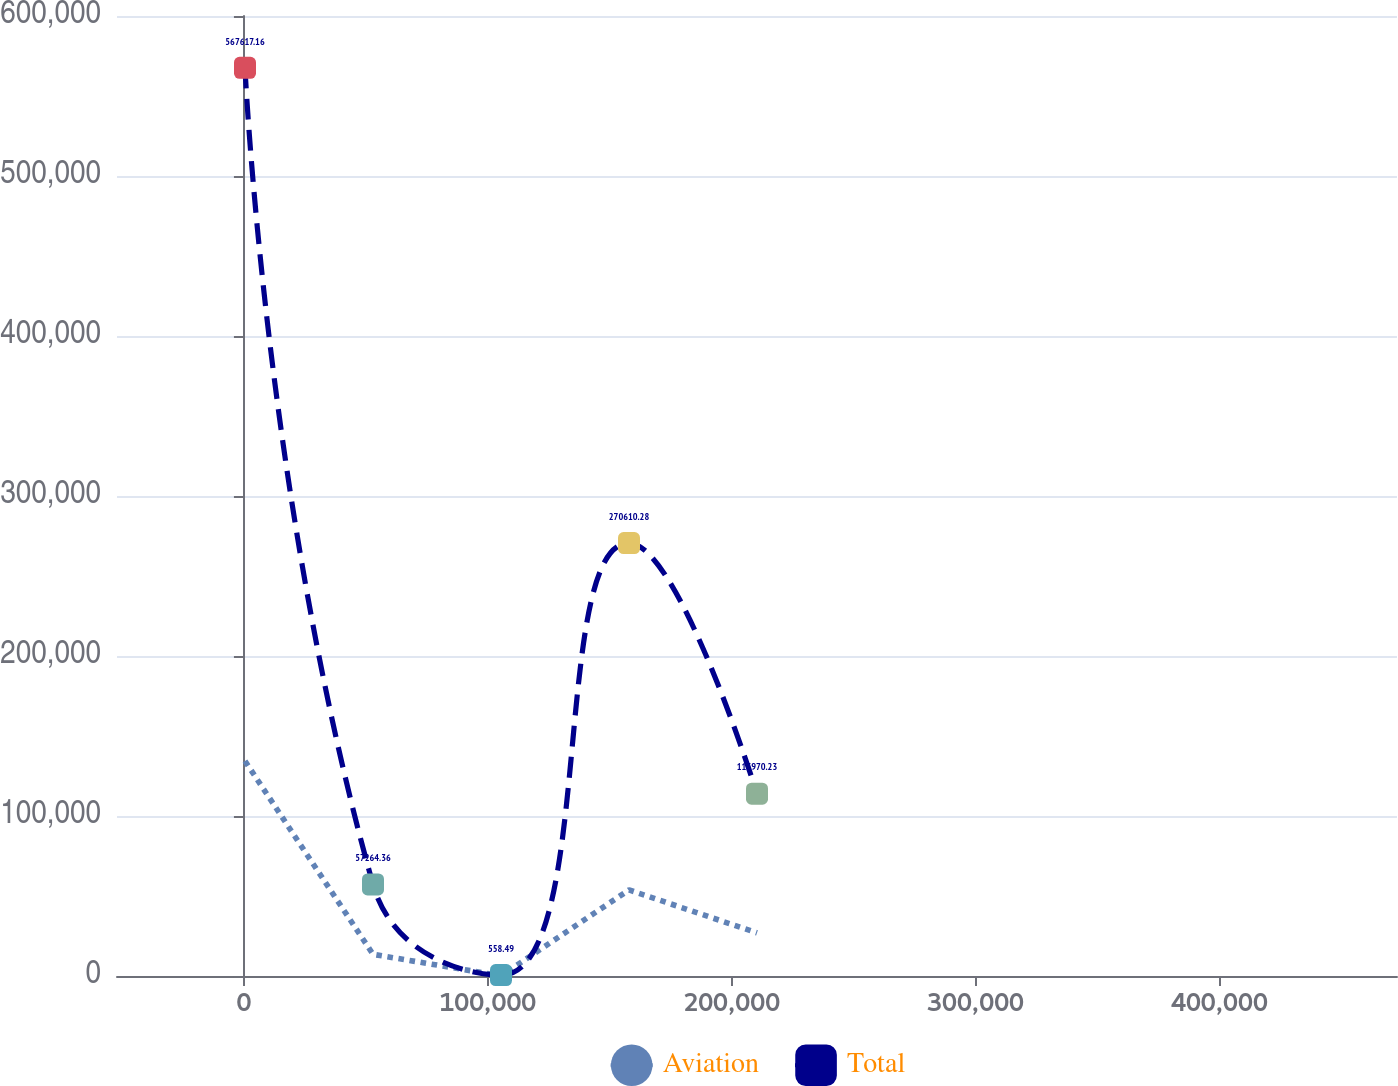<chart> <loc_0><loc_0><loc_500><loc_500><line_chart><ecel><fcel>Aviation<fcel>Total<nl><fcel>436.49<fcel>134334<fcel>567617<nl><fcel>52923.2<fcel>13547.8<fcel>57264.4<nl><fcel>105410<fcel>127.19<fcel>558.49<nl><fcel>157896<fcel>53809.7<fcel>270610<nl><fcel>210383<fcel>26968.5<fcel>113970<nl><fcel>525303<fcel>40389.1<fcel>170676<nl></chart> 